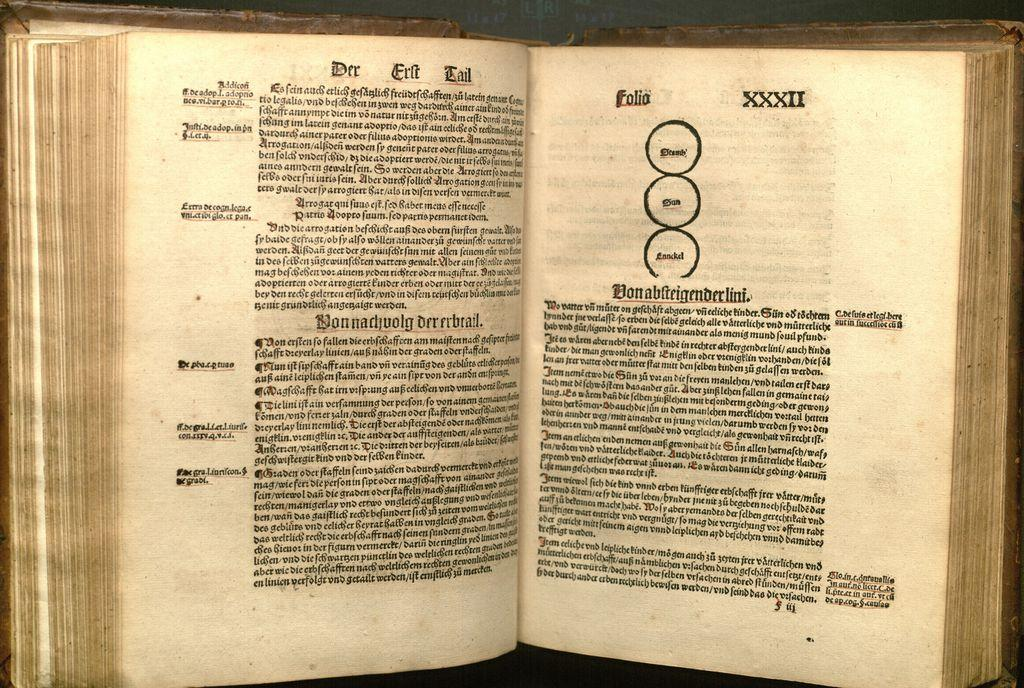<image>
Summarize the visual content of the image. An old book is open to a page with the heading Der Erft Tail. 